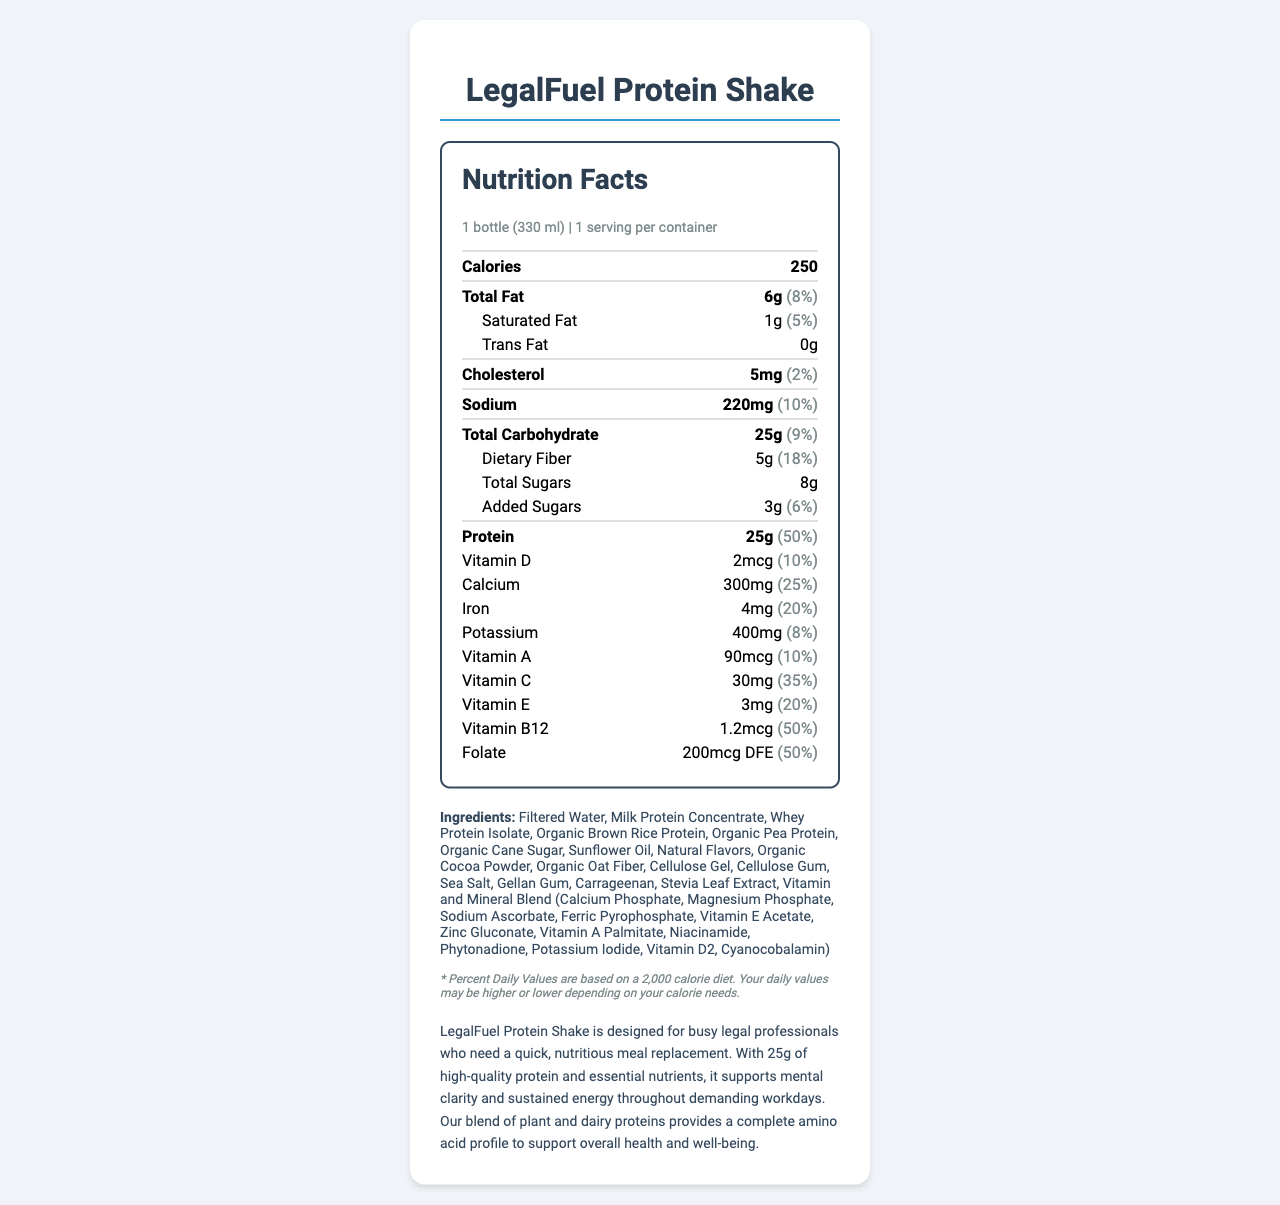what is the serving size of the LegalFuel Protein Shake? The serving size is clearly mentioned at the top of the nutrition facts section as "1 bottle (330 ml)".
Answer: 1 bottle (330 ml) how many calories does one serving of LegalFuel Protein Shake contain? The calorie information is prominently displayed next to the serving size information as "250 calories".
Answer: 250 calories what percentage of the daily value of protein does the LegalFuel Protein Shake provide? The protein content, along with its daily value percentage, is listed as "Protein 25g (50%)".
Answer: 50% list the main sources of protein in the LegalFuel Protein Shake. The ingredients section lists these as the main sources of protein.
Answer: Milk Protein Concentrate, Whey Protein Isolate, Organic Brown Rice Protein, Organic Pea Protein which vitamin is present in the highest daily value percentage? Vitamin B12 provides 50% of the daily value, which is the highest compared to other vitamins listed on the label.
Answer: Vitamin B12 how much sodium does one serving of the LegalFuel Protein Shake contain? The sodium content is shown in the nutrient list as "Sodium 220mg".
Answer: 220mg does the LegalFuel Protein Shake contain any trans fats? The document clearly lists "Trans Fat 0g" under the nutrient section.
Answer: No is the LegalFuel Protein Shake suitable for someone with a milk allergy? The allergen information states that the shake contains milk.
Answer: No which of the following vitamins is not listed in the LegalFuel Protein Shake? A. Vitamin K B. Vitamin D C. Vitamin E D. Vitamin A Vitamin K is not listed in the document, while the other vitamins are present.
Answer: A what is the total carbohydrate content per serving? A. 15g B. 20g C. 25g D. 30g The carbohydrate content is listed as "Total Carbohydrate 25g".
Answer: C does the LegalFuel Protein Shake contain any added sugars? The document lists "Added Sugars" with an amount of 3g, indicating that it contains added sugars.
Answer: Yes provide a summary of the LegalFuel Protein Shake's nutritional highlights and main purpose. The summary is based on the product description and nutritional highlights detailed in the document.
Answer: The LegalFuel Protein Shake is a meal replacement designed for busy professionals with 25g of protein per serving, 250 calories, 8% total fat, 9% total carbohydrate, and 50% daily value of protein. It contains a blend of plant and dairy proteins, vitamins, and minerals to support mental clarity and sustained energy. which ingredient is used as a natural flavoring agent in the LegalFuel Protein Shake? The ingredients section lists "Stevia Leaf Extract" as one of the components, indicating it's used as a natural flavoring agent.
Answer: Stevia Leaf Extract how much dietary fiber is in one serving of LegalFuel Protein Shake, and what is its daily value percentage? The dietary fiber content and its percentage of the daily value are indicated as "Dietary Fiber 5g (18%)".
Answer: 5g, 18% what is the main idea conveyed about the LegalFuel Protein Shake in the product description? The main idea is centered around its purpose as a convenient meal replacement with adequate nutrition.
Answer: It is designed for busy professionals as a nutritious meal replacement containing high-quality protein and essential nutrients for mental clarity and sustained energy. where is the facility that produces LegalFuel Protein Shake mention its processing of tree nuts? The document states: "Produced in a facility that also processes soy and tree nuts" within the allergen information.
Answer: The allergen information section mentions this. how long has the LegalFuel Protein Shake been in the market? The document does not provide any information about the duration this product has been in the market.
Answer: I don't know is the nutrition facts layout easy to read and understand for consumers? The nutrition facts section is neatly organized with clear headings and values, making it easy for consumers to read and interpret the information.
Answer: Yes 